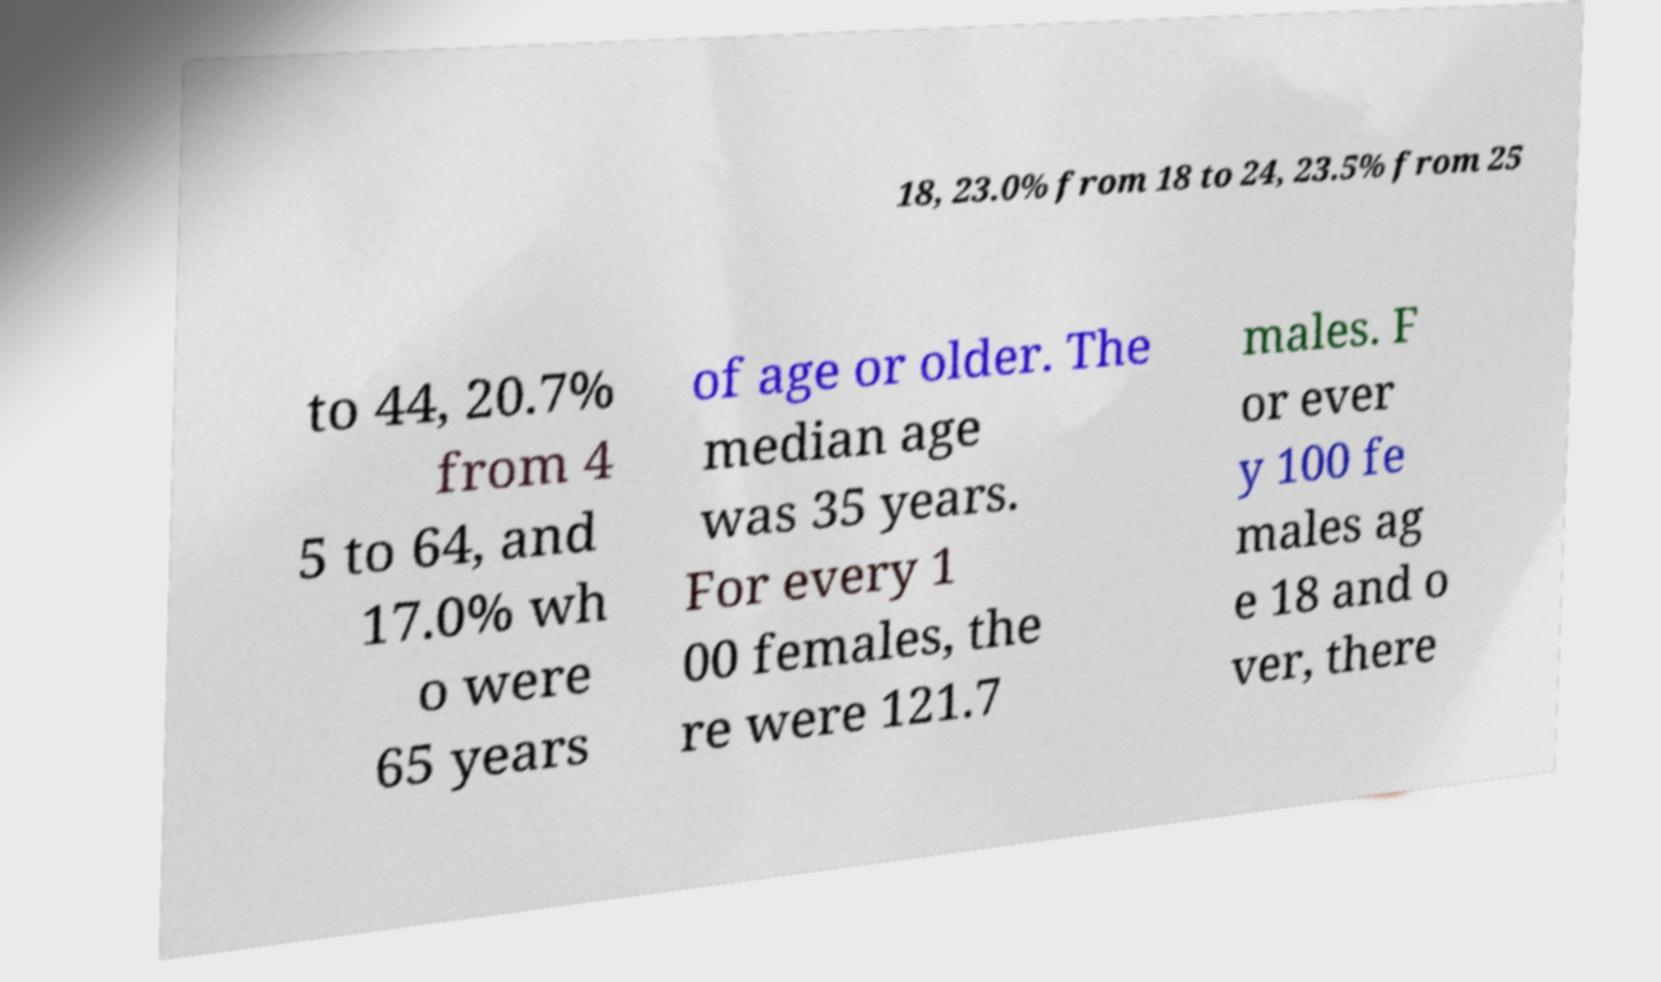I need the written content from this picture converted into text. Can you do that? 18, 23.0% from 18 to 24, 23.5% from 25 to 44, 20.7% from 4 5 to 64, and 17.0% wh o were 65 years of age or older. The median age was 35 years. For every 1 00 females, the re were 121.7 males. F or ever y 100 fe males ag e 18 and o ver, there 